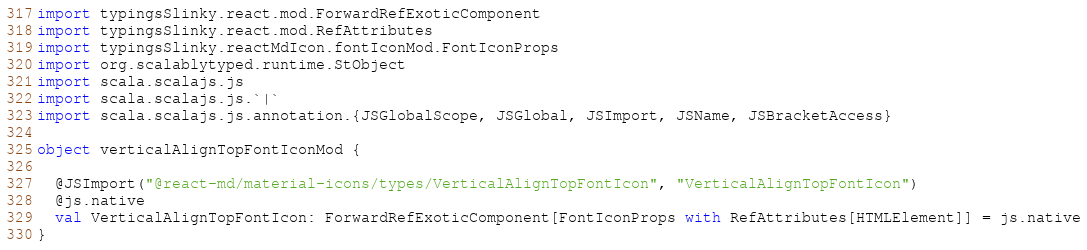<code> <loc_0><loc_0><loc_500><loc_500><_Scala_>import typingsSlinky.react.mod.ForwardRefExoticComponent
import typingsSlinky.react.mod.RefAttributes
import typingsSlinky.reactMdIcon.fontIconMod.FontIconProps
import org.scalablytyped.runtime.StObject
import scala.scalajs.js
import scala.scalajs.js.`|`
import scala.scalajs.js.annotation.{JSGlobalScope, JSGlobal, JSImport, JSName, JSBracketAccess}

object verticalAlignTopFontIconMod {
  
  @JSImport("@react-md/material-icons/types/VerticalAlignTopFontIcon", "VerticalAlignTopFontIcon")
  @js.native
  val VerticalAlignTopFontIcon: ForwardRefExoticComponent[FontIconProps with RefAttributes[HTMLElement]] = js.native
}
</code> 